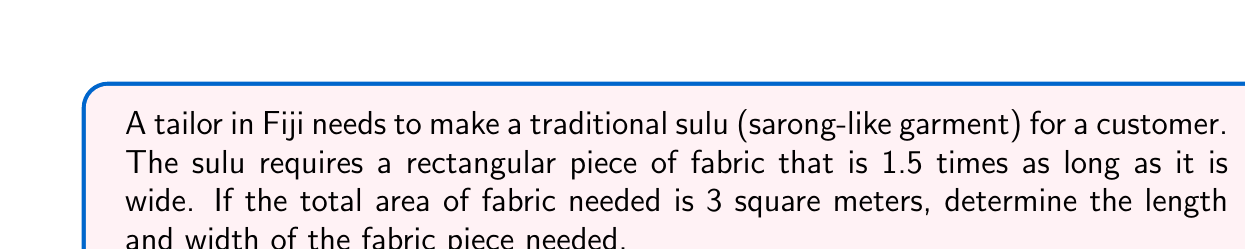Teach me how to tackle this problem. Let's solve this step-by-step:

1) Let the width of the fabric be $x$ meters.
2) The length is 1.5 times the width, so it's $1.5x$ meters.
3) The area of a rectangle is length times width. We're told the area is 3 square meters. So we can write:

   $$ x \cdot 1.5x = 3 $$

4) Simplify the left side of the equation:

   $$ 1.5x^2 = 3 $$

5) Divide both sides by 1.5:

   $$ x^2 = \frac{3}{1.5} = 2 $$

6) Take the square root of both sides:

   $$ x = \sqrt{2} \approx 1.414 $$

7) So the width is approximately 1.414 meters.

8) The length is 1.5 times this:

   $$ 1.5 \cdot 1.414 \approx 2.121 $$

Therefore, the fabric needed is approximately 1.414 meters wide and 2.121 meters long.
Answer: Width: $\sqrt{2}$ m, Length: $1.5\sqrt{2}$ m 